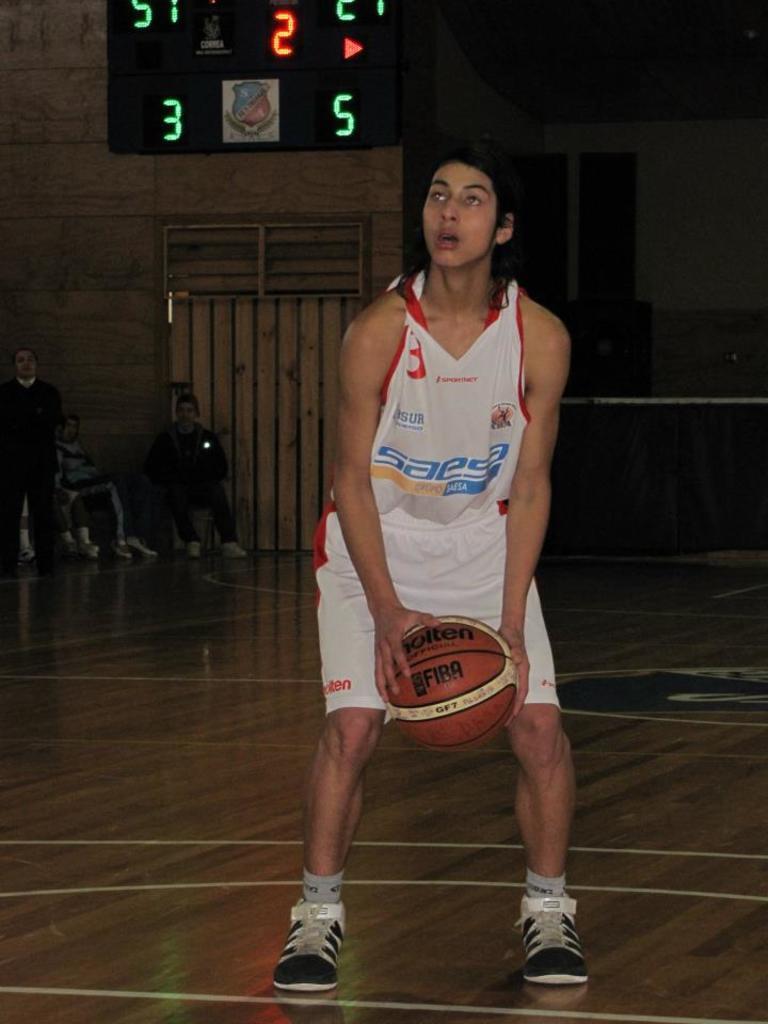What is the jersey sponsor?
Provide a short and direct response. Unanswerable. What is the current score?
Offer a terse response. 3 to 5. 